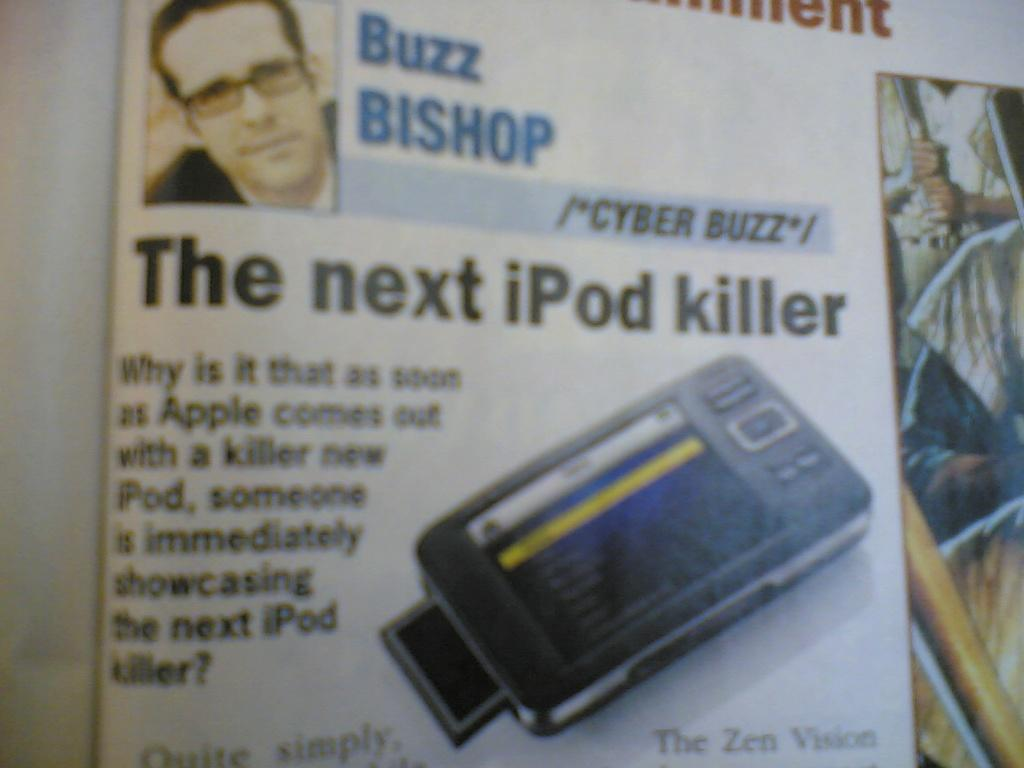What is the main subject of the image within the image? The main subject of the image within the image is a paper. What can be found on the paper? The paper contains text, images of persons, and an image of an electronic gadget. Is there a stream of water visible in the image? No, there is no stream of water visible in the image. 